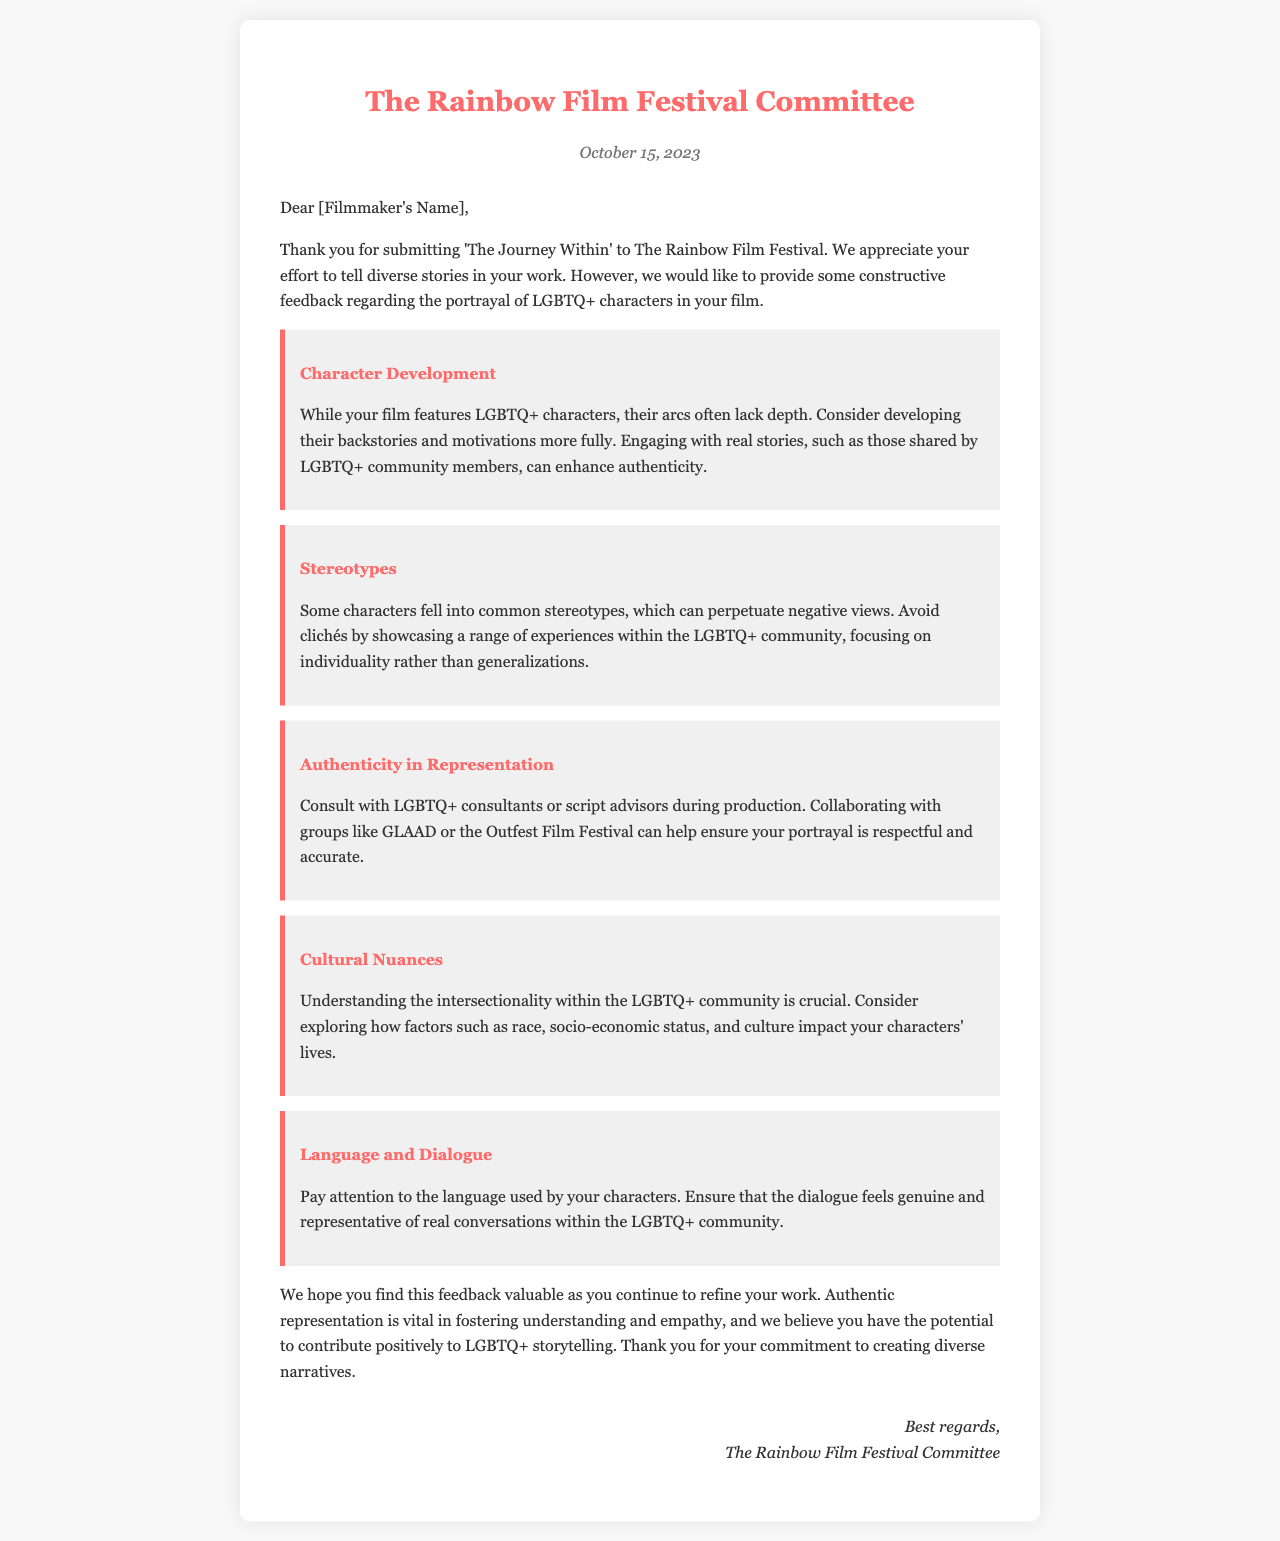What is the name of the festival? The name of the festival is mentioned in the header of the letter.
Answer: The Rainbow Film Festival What is the film title submitted? The film title is provided in the introduction of the letter.
Answer: The Journey Within What date is the letter dated? The date is clearly specified in the header section of the letter.
Answer: October 15, 2023 What is one suggestion for improving character development? The letter includes specific suggestions in the improvement points.
Answer: Developing backstories Which organization is mentioned for consultation during production? The letter suggests specific organizations for consultation in the authenticity section.
Answer: GLAAD What is highlighted as important for authenticity in representation? The letter emphasizes key aspects regarding authenticity in its content.
Answer: Consulting with LGBTQ+ consultants How many areas of improvement are mentioned in the letter? The number of areas is indicated by the individual improvement points listed in the document.
Answer: Five What type of language should be used by the characters? The letter notes the need for a specific type of dialogue in the language section.
Answer: Genuine What is the tone of the feedback given in the letter? The overall tone can be inferred from the language and content of the letter.
Answer: Constructive 